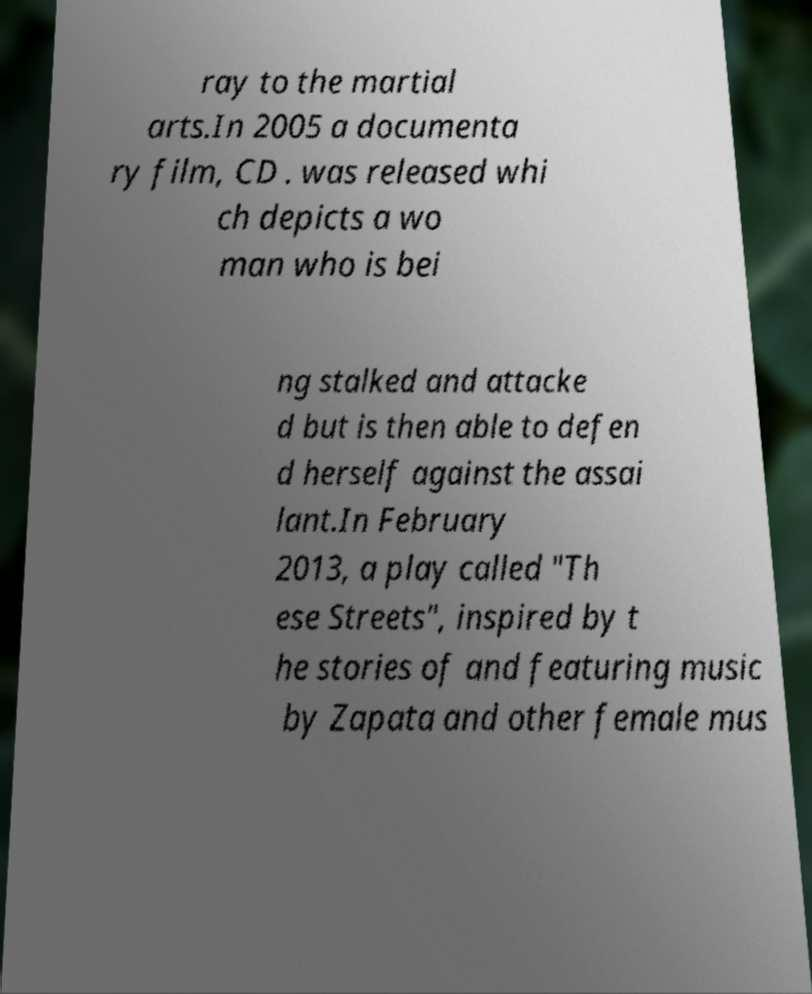I need the written content from this picture converted into text. Can you do that? ray to the martial arts.In 2005 a documenta ry film, CD . was released whi ch depicts a wo man who is bei ng stalked and attacke d but is then able to defen d herself against the assai lant.In February 2013, a play called "Th ese Streets", inspired by t he stories of and featuring music by Zapata and other female mus 